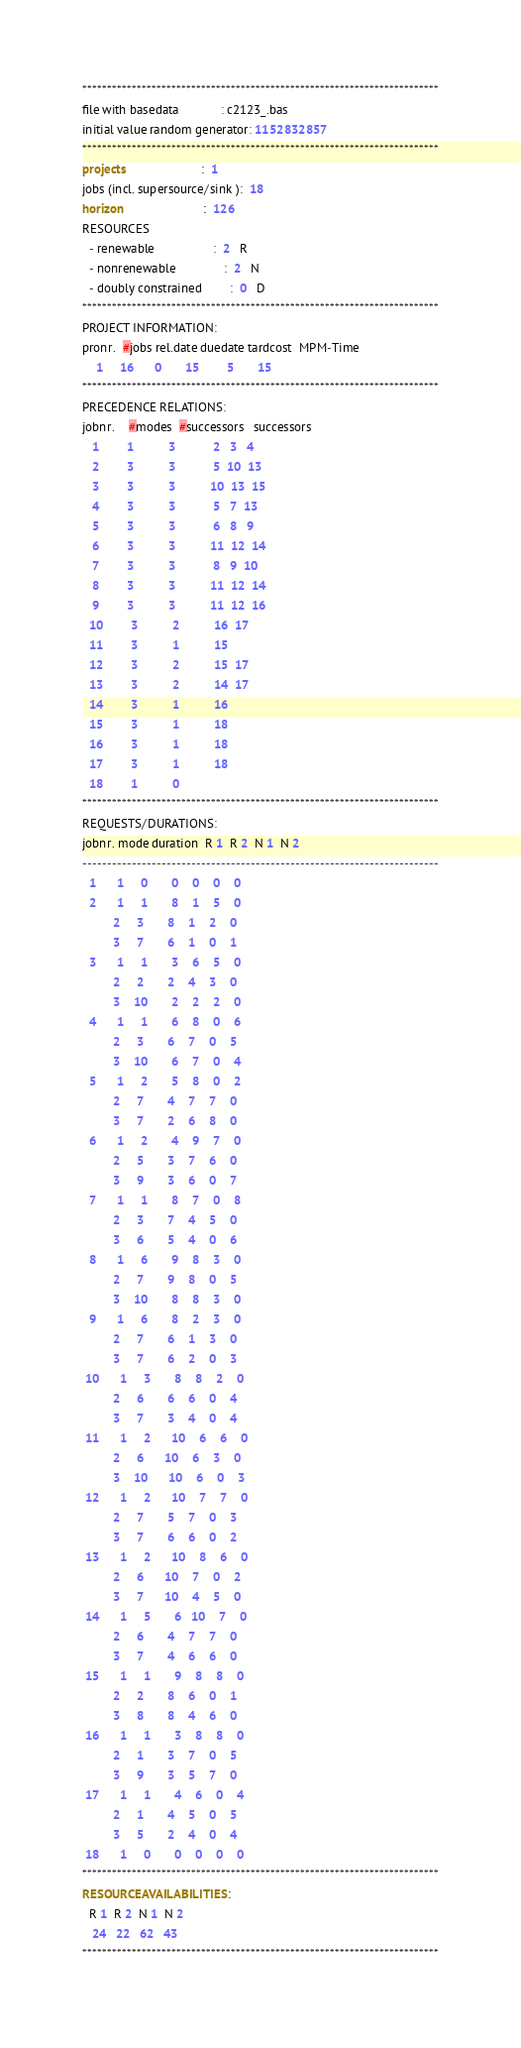Convert code to text. <code><loc_0><loc_0><loc_500><loc_500><_ObjectiveC_>************************************************************************
file with basedata            : c2123_.bas
initial value random generator: 1152832857
************************************************************************
projects                      :  1
jobs (incl. supersource/sink ):  18
horizon                       :  126
RESOURCES
  - renewable                 :  2   R
  - nonrenewable              :  2   N
  - doubly constrained        :  0   D
************************************************************************
PROJECT INFORMATION:
pronr.  #jobs rel.date duedate tardcost  MPM-Time
    1     16      0       15        5       15
************************************************************************
PRECEDENCE RELATIONS:
jobnr.    #modes  #successors   successors
   1        1          3           2   3   4
   2        3          3           5  10  13
   3        3          3          10  13  15
   4        3          3           5   7  13
   5        3          3           6   8   9
   6        3          3          11  12  14
   7        3          3           8   9  10
   8        3          3          11  12  14
   9        3          3          11  12  16
  10        3          2          16  17
  11        3          1          15
  12        3          2          15  17
  13        3          2          14  17
  14        3          1          16
  15        3          1          18
  16        3          1          18
  17        3          1          18
  18        1          0        
************************************************************************
REQUESTS/DURATIONS:
jobnr. mode duration  R 1  R 2  N 1  N 2
------------------------------------------------------------------------
  1      1     0       0    0    0    0
  2      1     1       8    1    5    0
         2     3       8    1    2    0
         3     7       6    1    0    1
  3      1     1       3    6    5    0
         2     2       2    4    3    0
         3    10       2    2    2    0
  4      1     1       6    8    0    6
         2     3       6    7    0    5
         3    10       6    7    0    4
  5      1     2       5    8    0    2
         2     7       4    7    7    0
         3     7       2    6    8    0
  6      1     2       4    9    7    0
         2     5       3    7    6    0
         3     9       3    6    0    7
  7      1     1       8    7    0    8
         2     3       7    4    5    0
         3     6       5    4    0    6
  8      1     6       9    8    3    0
         2     7       9    8    0    5
         3    10       8    8    3    0
  9      1     6       8    2    3    0
         2     7       6    1    3    0
         3     7       6    2    0    3
 10      1     3       8    8    2    0
         2     6       6    6    0    4
         3     7       3    4    0    4
 11      1     2      10    6    6    0
         2     6      10    6    3    0
         3    10      10    6    0    3
 12      1     2      10    7    7    0
         2     7       5    7    0    3
         3     7       6    6    0    2
 13      1     2      10    8    6    0
         2     6      10    7    0    2
         3     7      10    4    5    0
 14      1     5       6   10    7    0
         2     6       4    7    7    0
         3     7       4    6    6    0
 15      1     1       9    8    8    0
         2     2       8    6    0    1
         3     8       8    4    6    0
 16      1     1       3    8    8    0
         2     1       3    7    0    5
         3     9       3    5    7    0
 17      1     1       4    6    0    4
         2     1       4    5    0    5
         3     5       2    4    0    4
 18      1     0       0    0    0    0
************************************************************************
RESOURCEAVAILABILITIES:
  R 1  R 2  N 1  N 2
   24   22   62   43
************************************************************************
</code> 